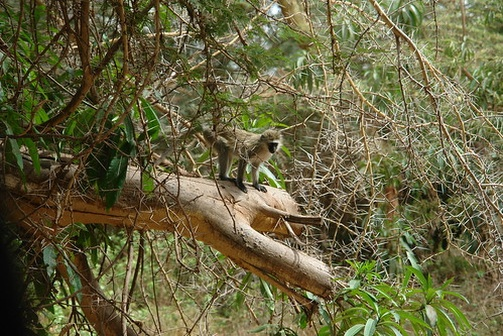Describe the environment and the possible daily activities of the monkey in this forest. The forest is a lush, green haven filled with tall trees, dense foliage, and tangled branches. The abundance of leaves and vegetation indicates a healthy ecosystem, thriving with life. The monkey likely spends its days hopping from branch to branch, foraging for fruits, leaves, insects, and other nourishing foods. It may engage in social activities with other monkeys, playing or grooming each other, which strengthens their social bonds. The forest offers plenty of opportunities for exploration, with the monkey discovering new sights and scents each day, while also staying vigilant for predators. At night, the monkey might find a safe perch high in the trees to sleep, sheltered from the forest floor's dangers. 